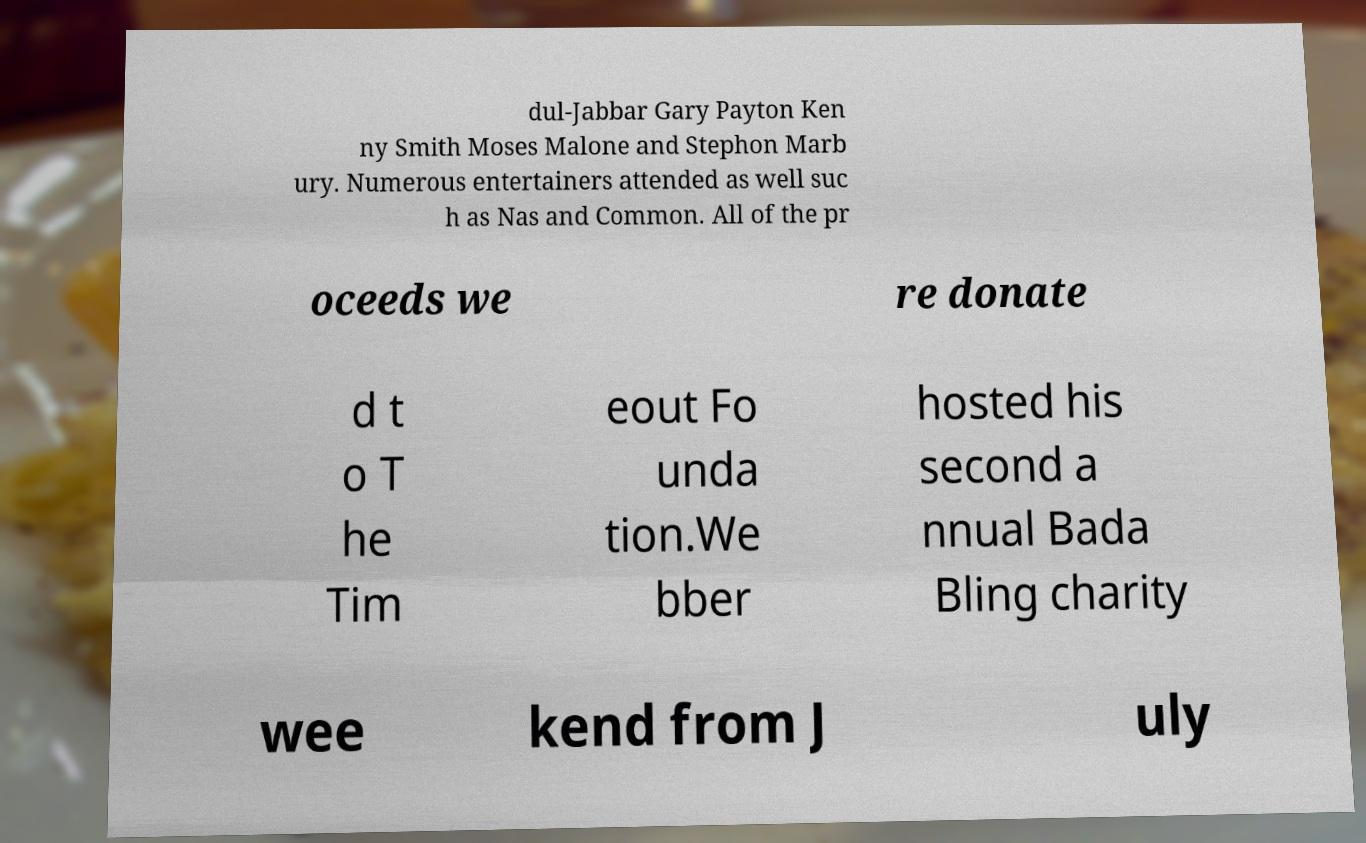Could you extract and type out the text from this image? dul-Jabbar Gary Payton Ken ny Smith Moses Malone and Stephon Marb ury. Numerous entertainers attended as well suc h as Nas and Common. All of the pr oceeds we re donate d t o T he Tim eout Fo unda tion.We bber hosted his second a nnual Bada Bling charity wee kend from J uly 